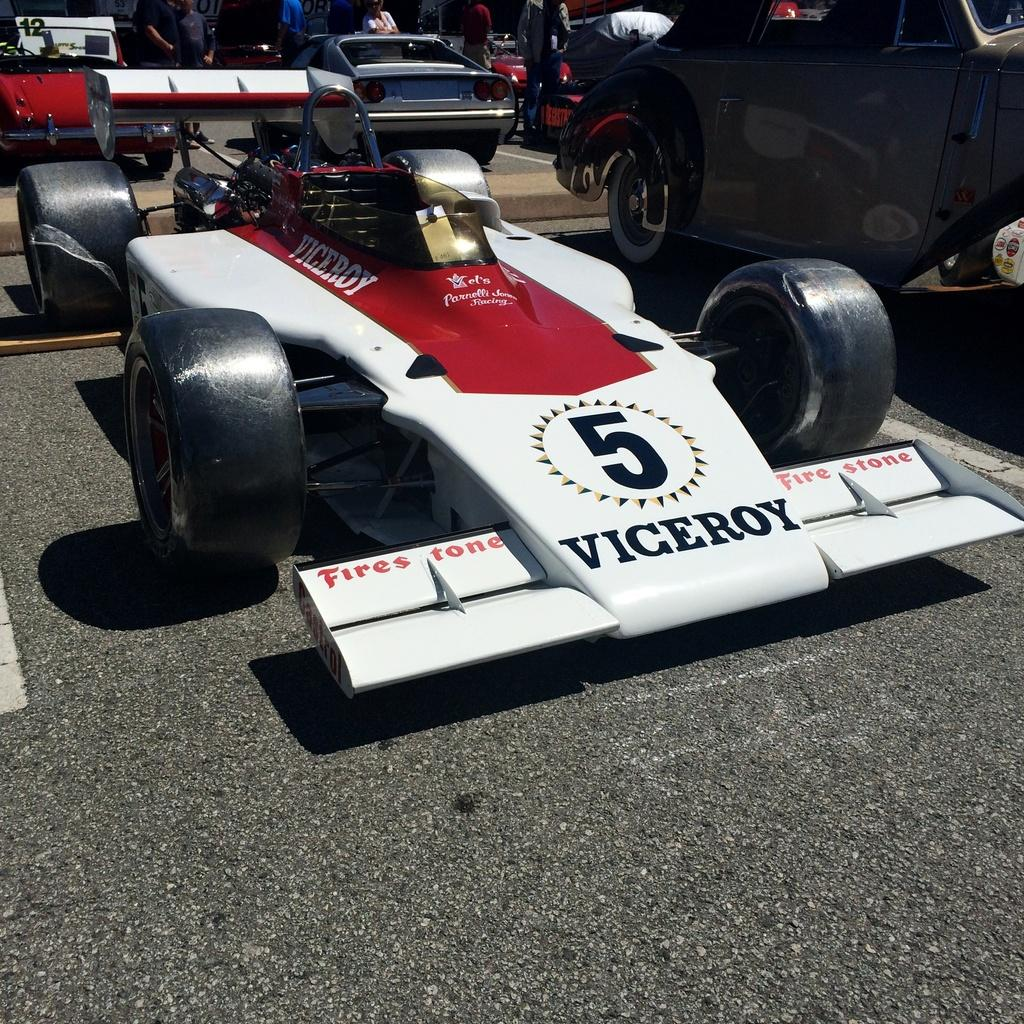What is the main subject of the image? The main subject of the image is a car. Can you describe the color of the car? The car is white and red in color. What else can be seen in the background of the image? There are vehicles and people standing in the background of the image. What type of theory is being discussed by the people standing in the background of the image? There is no indication in the image that the people are discussing any theories, so it cannot be determined from the picture. 